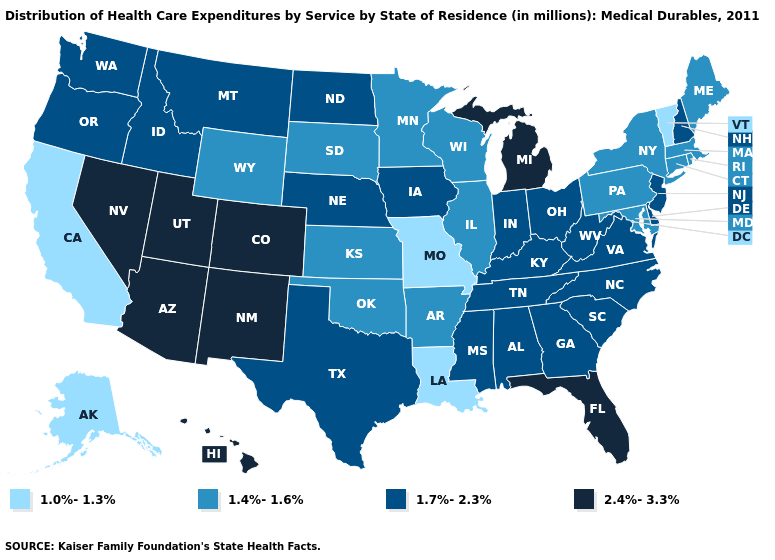Name the states that have a value in the range 1.4%-1.6%?
Short answer required. Arkansas, Connecticut, Illinois, Kansas, Maine, Maryland, Massachusetts, Minnesota, New York, Oklahoma, Pennsylvania, Rhode Island, South Dakota, Wisconsin, Wyoming. Does Wyoming have the highest value in the West?
Write a very short answer. No. What is the value of Indiana?
Short answer required. 1.7%-2.3%. What is the value of Nebraska?
Write a very short answer. 1.7%-2.3%. What is the value of Georgia?
Concise answer only. 1.7%-2.3%. Is the legend a continuous bar?
Keep it brief. No. Name the states that have a value in the range 1.4%-1.6%?
Give a very brief answer. Arkansas, Connecticut, Illinois, Kansas, Maine, Maryland, Massachusetts, Minnesota, New York, Oklahoma, Pennsylvania, Rhode Island, South Dakota, Wisconsin, Wyoming. Is the legend a continuous bar?
Be succinct. No. Which states have the highest value in the USA?
Give a very brief answer. Arizona, Colorado, Florida, Hawaii, Michigan, Nevada, New Mexico, Utah. Among the states that border Minnesota , which have the highest value?
Short answer required. Iowa, North Dakota. What is the value of Maine?
Concise answer only. 1.4%-1.6%. Is the legend a continuous bar?
Write a very short answer. No. Does the first symbol in the legend represent the smallest category?
Concise answer only. Yes. Among the states that border Kentucky , does Illinois have the highest value?
Write a very short answer. No. How many symbols are there in the legend?
Quick response, please. 4. 